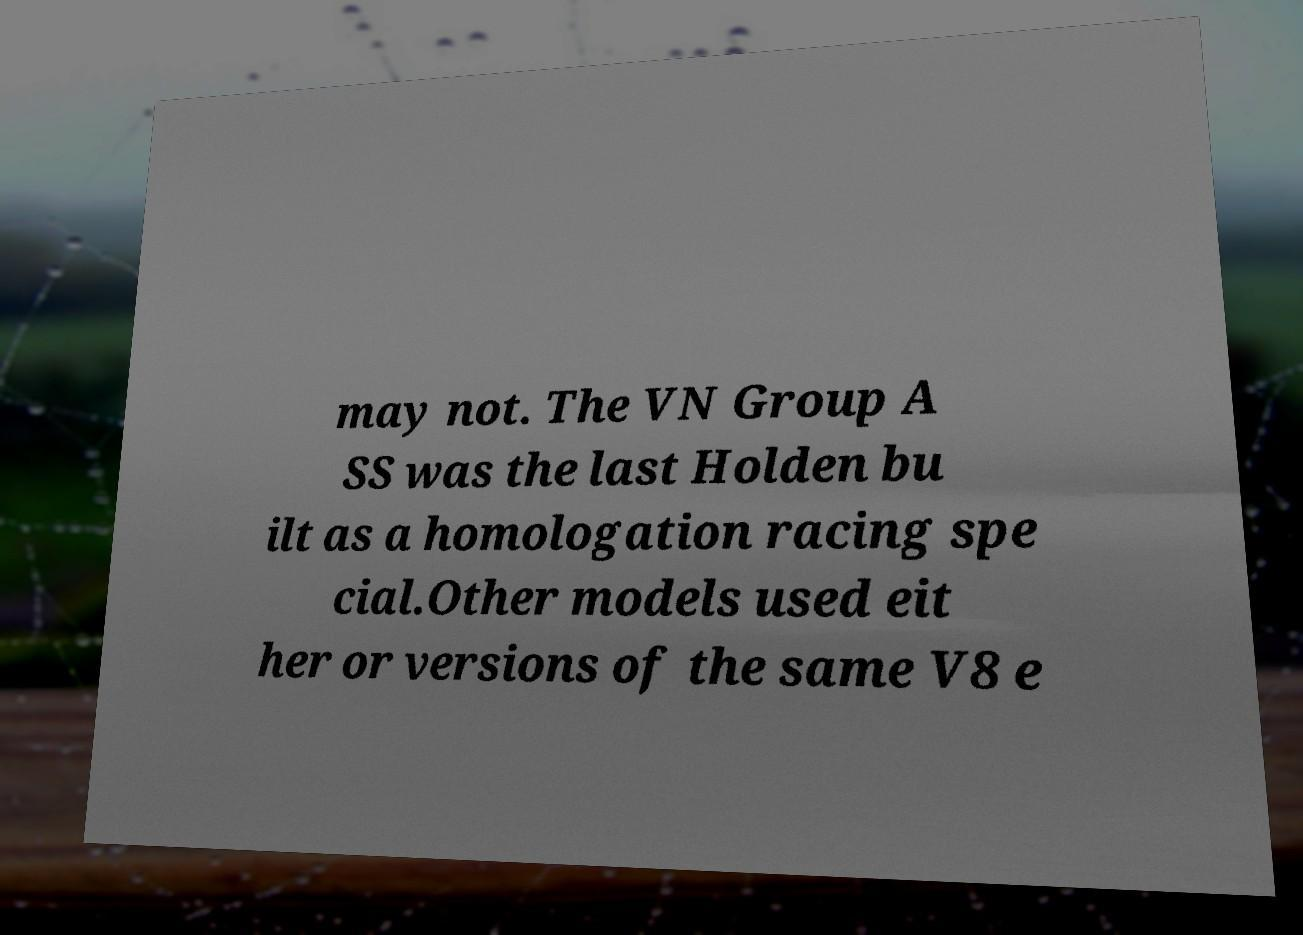I need the written content from this picture converted into text. Can you do that? may not. The VN Group A SS was the last Holden bu ilt as a homologation racing spe cial.Other models used eit her or versions of the same V8 e 